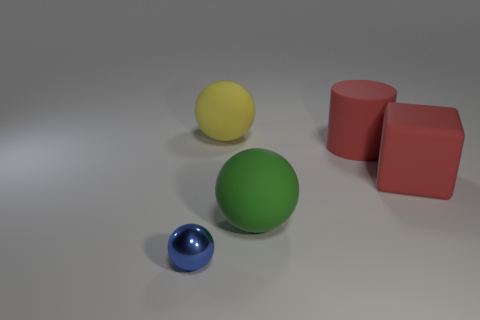What can you deduce about the light source in this image based on the shadows? The light source appears to be coming from the top left, as indicated by the placement of the shadows to the right of objects. The softness of the shadows suggests that the light is diffused, possibly by a larger light source or through some kind of filtering. 